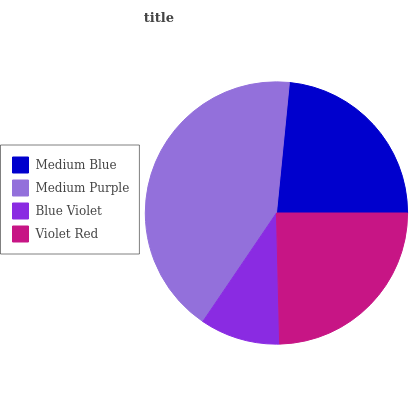Is Blue Violet the minimum?
Answer yes or no. Yes. Is Medium Purple the maximum?
Answer yes or no. Yes. Is Medium Purple the minimum?
Answer yes or no. No. Is Blue Violet the maximum?
Answer yes or no. No. Is Medium Purple greater than Blue Violet?
Answer yes or no. Yes. Is Blue Violet less than Medium Purple?
Answer yes or no. Yes. Is Blue Violet greater than Medium Purple?
Answer yes or no. No. Is Medium Purple less than Blue Violet?
Answer yes or no. No. Is Violet Red the high median?
Answer yes or no. Yes. Is Medium Blue the low median?
Answer yes or no. Yes. Is Blue Violet the high median?
Answer yes or no. No. Is Violet Red the low median?
Answer yes or no. No. 